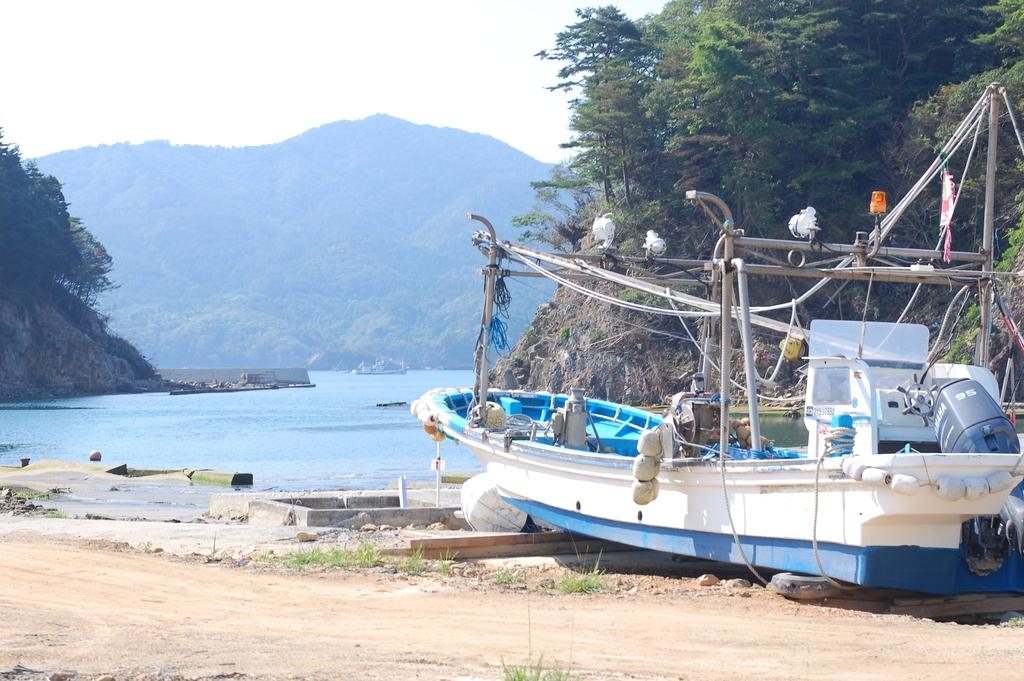What is the main subject of the image? The main subject of the image is a boat. Can you describe the boat's appearance? The boat is white. Where is the boat located in the image? The boat is on the right side of the image. What is the primary setting of the image? There is water in the image. Can you describe the water's location in the image? The water is in the middle of the image. What other features can be seen in the image? There are hills visible in the image. How many jars of current are on the boat in the image? There are no jars or current present in the image. What type of clocks can be seen on the hills in the image? There are no clocks visible in the image; only the boat, water, and hills can be seen. 